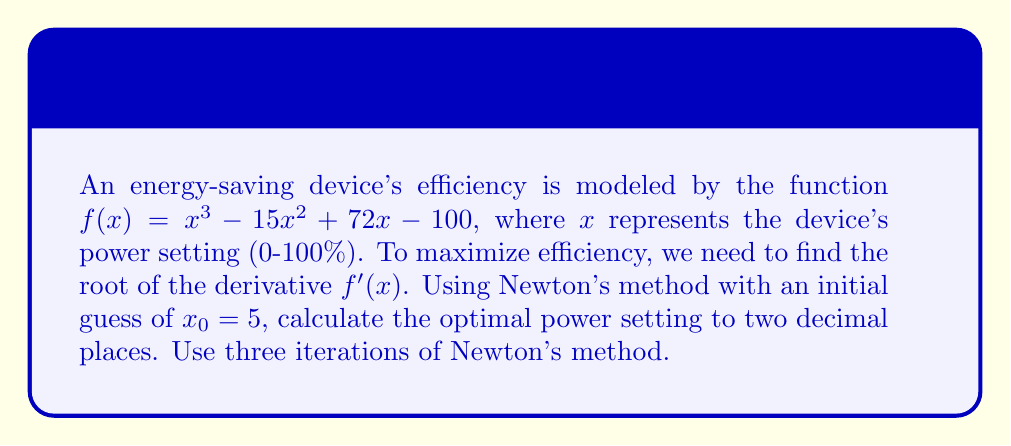Help me with this question. 1) First, we need to find the derivative of $f(x)$:
   $f'(x) = 3x^2 - 30x + 72$

2) Newton's method formula:
   $x_{n+1} = x_n - \frac{f'(x_n)}{f''(x_n)}$

3) Calculate $f''(x)$:
   $f''(x) = 6x - 30$

4) Iteration 1:
   $x_1 = 5 - \frac{3(5)^2 - 30(5) + 72}{6(5) - 30} = 5 - \frac{-3}{0} = \text{undefined}$

   The first iteration fails because $f''(5) = 0$. Let's choose a new initial guess: $x_0 = 6$

5) Iteration 1 (revised):
   $x_1 = 6 - \frac{3(6)^2 - 30(6) + 72}{6(6) - 30} = 6 - \frac{0}{6} = 6$

6) Iteration 2:
   $x_2 = 6 - \frac{3(6)^2 - 30(6) + 72}{6(6) - 30} = 6 - \frac{0}{6} = 6$

7) Iteration 3:
   $x_3 = 6 - \frac{3(6)^2 - 30(6) + 72}{6(6) - 30} = 6 - \frac{0}{6} = 6$

The method converges to $x = 6$, which is the optimal power setting.
Answer: 6.00% 